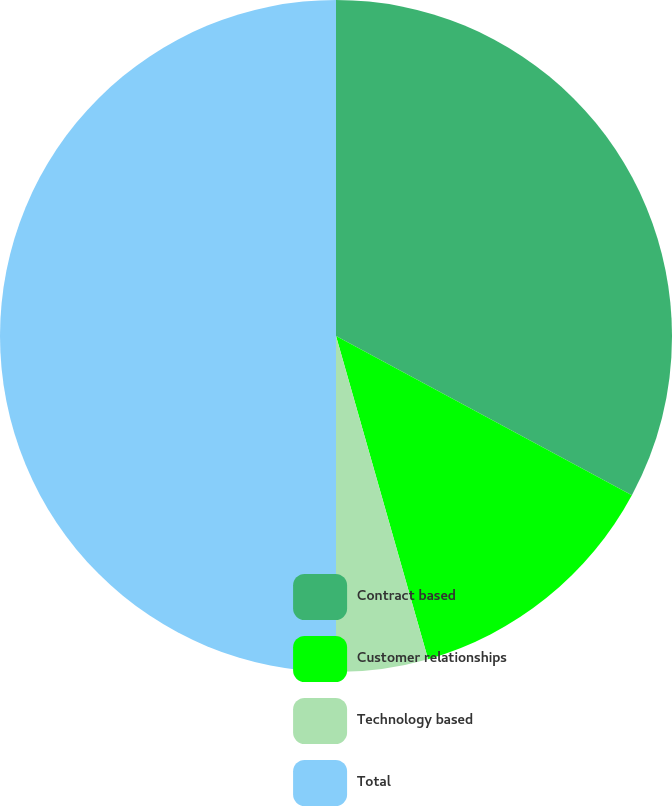Convert chart to OTSL. <chart><loc_0><loc_0><loc_500><loc_500><pie_chart><fcel>Contract based<fcel>Customer relationships<fcel>Technology based<fcel>Total<nl><fcel>32.86%<fcel>12.72%<fcel>4.42%<fcel>50.0%<nl></chart> 